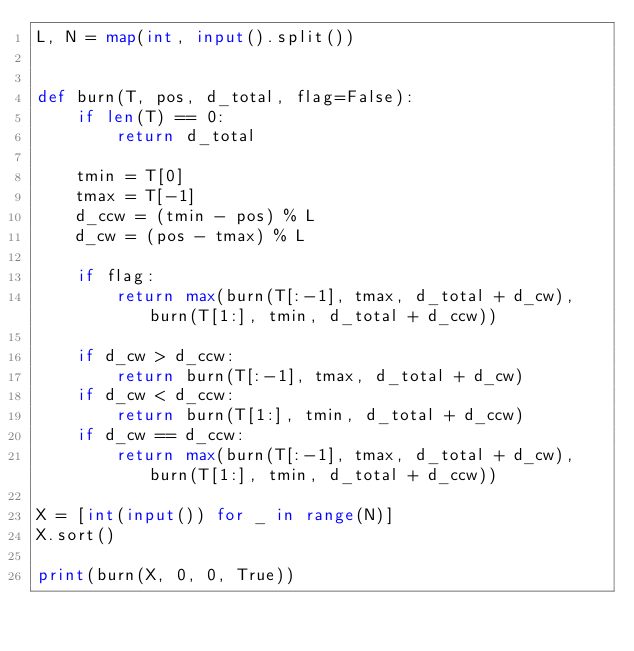Convert code to text. <code><loc_0><loc_0><loc_500><loc_500><_Python_>L, N = map(int, input().split())


def burn(T, pos, d_total, flag=False):
    if len(T) == 0:
        return d_total

    tmin = T[0]
    tmax = T[-1]
    d_ccw = (tmin - pos) % L
    d_cw = (pos - tmax) % L

    if flag:
        return max(burn(T[:-1], tmax, d_total + d_cw), burn(T[1:], tmin, d_total + d_ccw))

    if d_cw > d_ccw:
        return burn(T[:-1], tmax, d_total + d_cw)
    if d_cw < d_ccw:
        return burn(T[1:], tmin, d_total + d_ccw)
    if d_cw == d_ccw:
        return max(burn(T[:-1], tmax, d_total + d_cw), burn(T[1:], tmin, d_total + d_ccw))

X = [int(input()) for _ in range(N)]
X.sort()

print(burn(X, 0, 0, True))</code> 